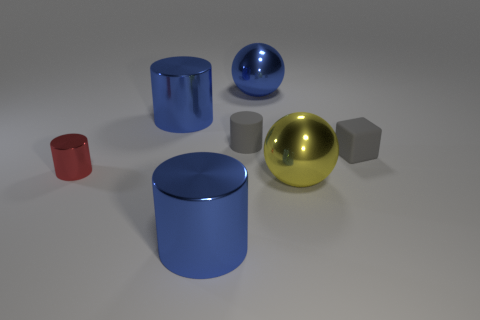Add 1 red cylinders. How many objects exist? 8 Subtract all cylinders. How many objects are left? 3 Add 2 small red things. How many small red things are left? 3 Add 2 metallic balls. How many metallic balls exist? 4 Subtract 0 gray spheres. How many objects are left? 7 Subtract all large brown spheres. Subtract all big blue shiny spheres. How many objects are left? 6 